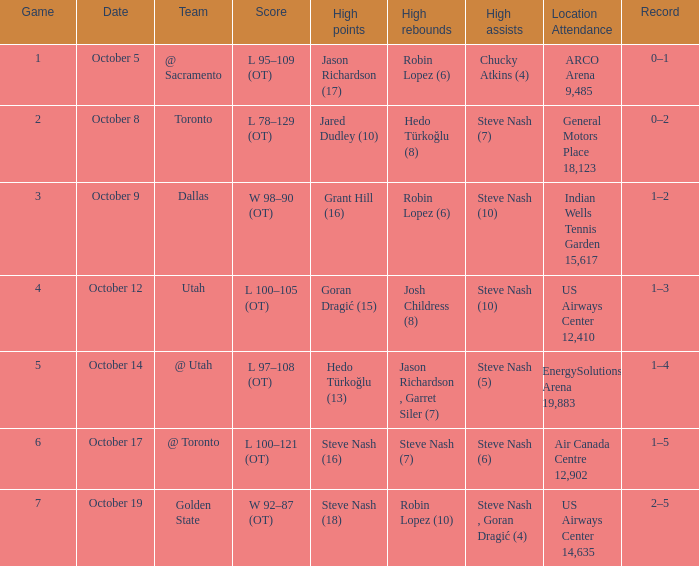How many games had Robin Lopez (10) for the most rebounds? 1.0. 